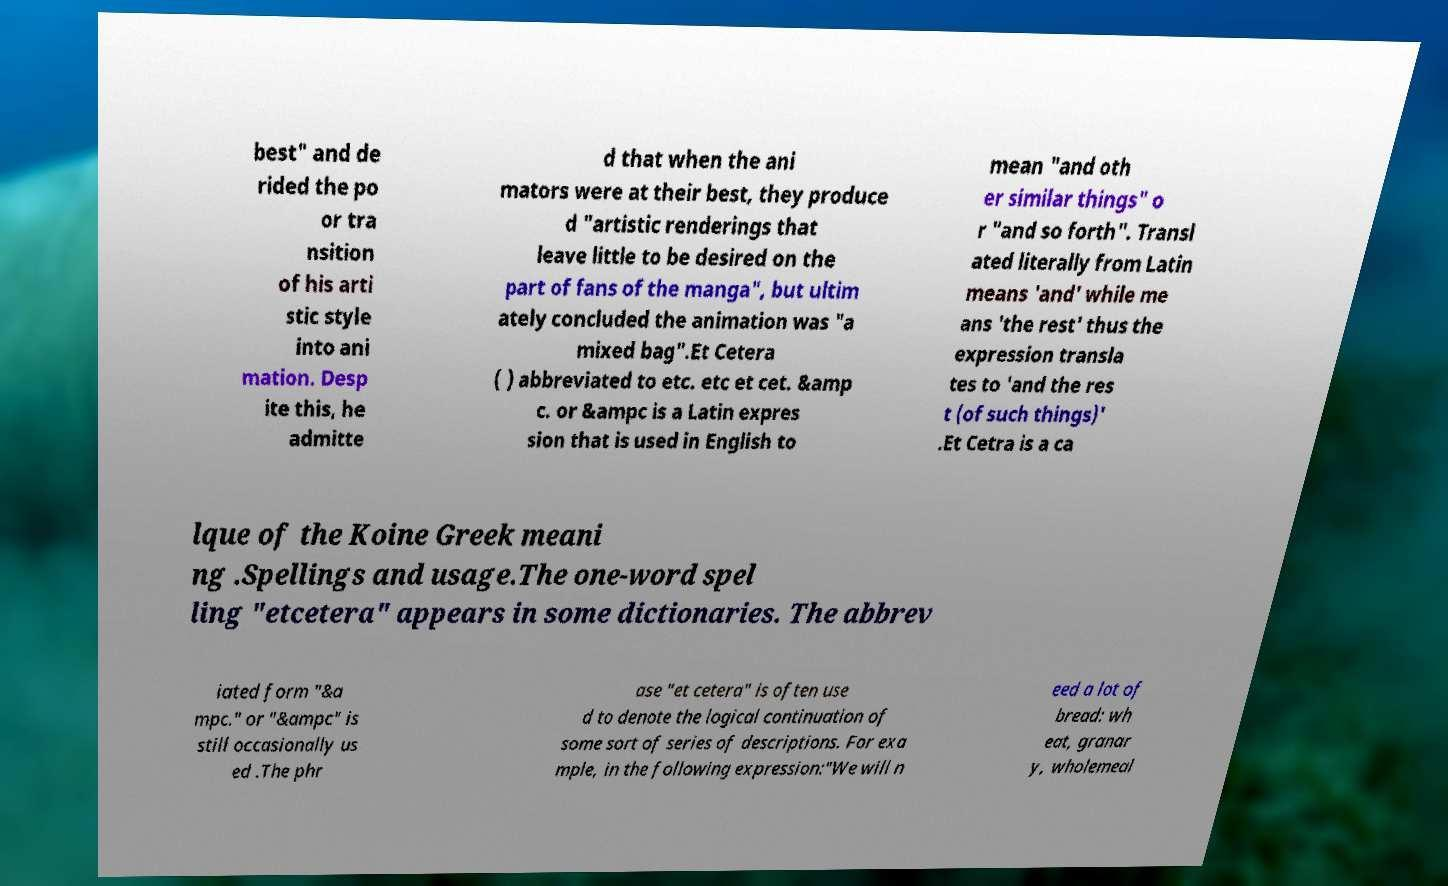I need the written content from this picture converted into text. Can you do that? best" and de rided the po or tra nsition of his arti stic style into ani mation. Desp ite this, he admitte d that when the ani mators were at their best, they produce d "artistic renderings that leave little to be desired on the part of fans of the manga", but ultim ately concluded the animation was "a mixed bag".Et Cetera ( ) abbreviated to etc. etc et cet. &amp c. or &ampc is a Latin expres sion that is used in English to mean "and oth er similar things" o r "and so forth". Transl ated literally from Latin means 'and' while me ans 'the rest' thus the expression transla tes to 'and the res t (of such things)' .Et Cetra is a ca lque of the Koine Greek meani ng .Spellings and usage.The one-word spel ling "etcetera" appears in some dictionaries. The abbrev iated form "&a mpc." or "&ampc" is still occasionally us ed .The phr ase "et cetera" is often use d to denote the logical continuation of some sort of series of descriptions. For exa mple, in the following expression:"We will n eed a lot of bread: wh eat, granar y, wholemeal 